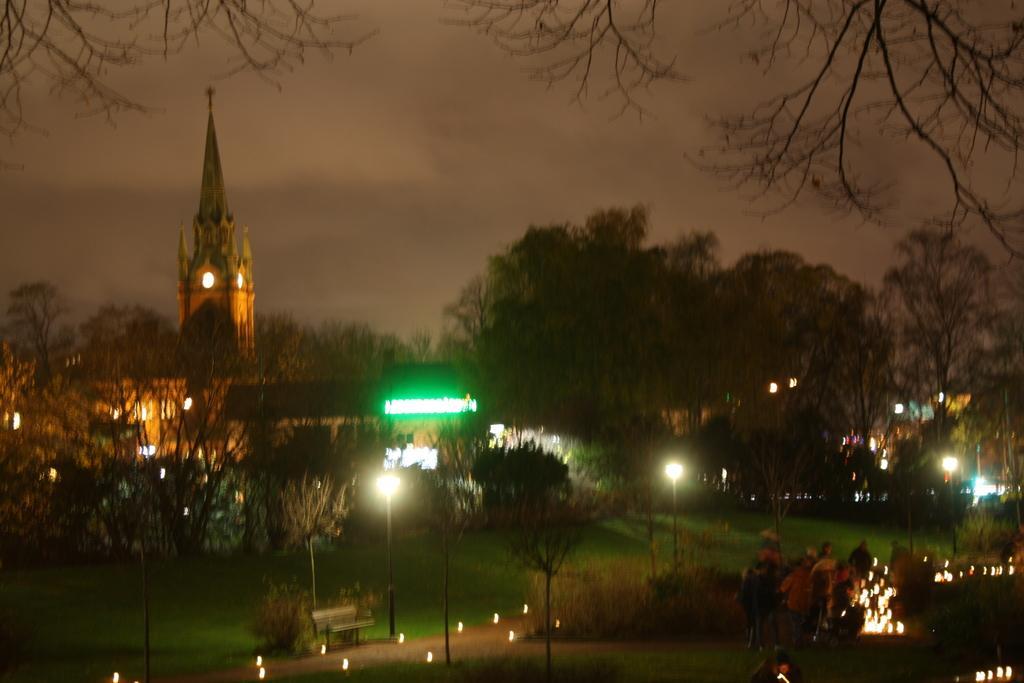In one or two sentences, can you explain what this image depicts? In this image I can see few trees,lights,bench and few people. Back Side I can see a building. The sky is cloudy. 